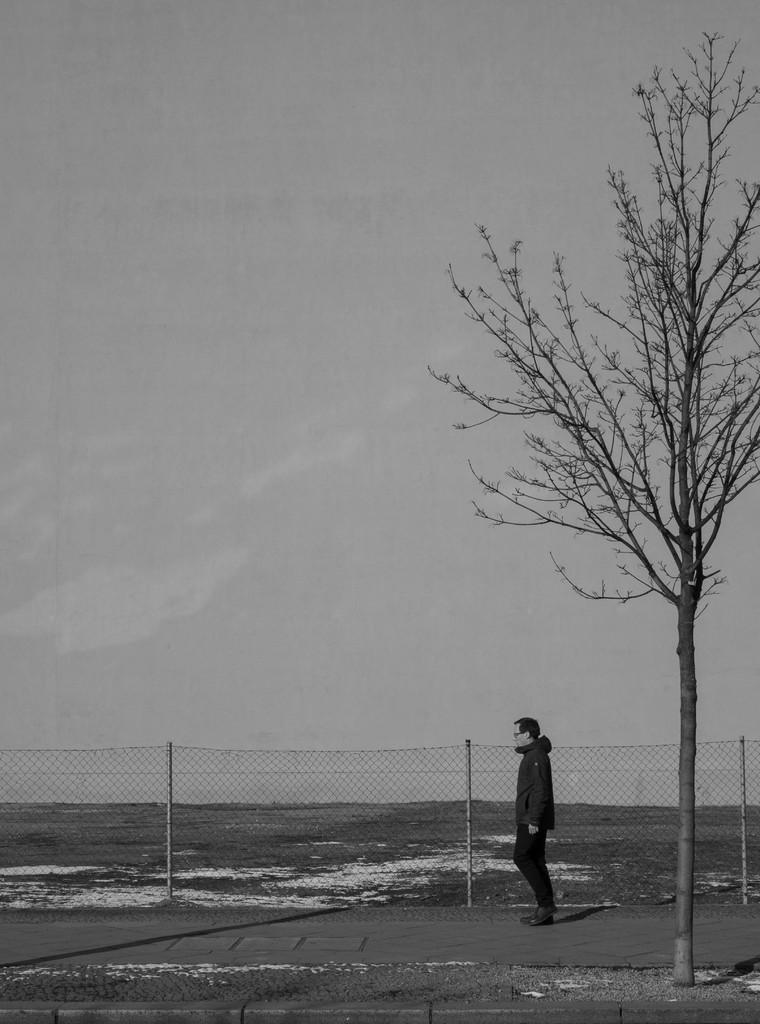Could you give a brief overview of what you see in this image? This image consists of a man wearing a black jacket. At the bottom, there is a pavement. Behind the man we can see a fencing. On the right, there is a tree. In the background, there are clouds in the sky. At the bottom, there is a snow. 